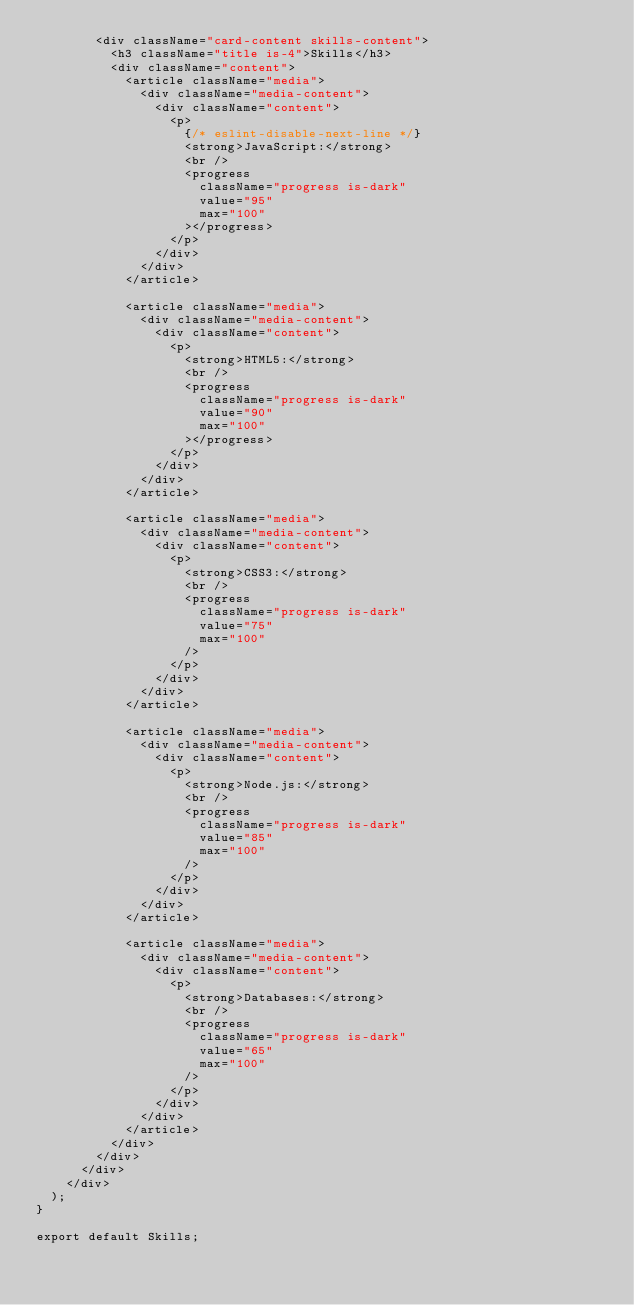<code> <loc_0><loc_0><loc_500><loc_500><_JavaScript_>        <div className="card-content skills-content">
          <h3 className="title is-4">Skills</h3>
          <div className="content">
            <article className="media">
              <div className="media-content">
                <div className="content">
                  <p>
                    {/* eslint-disable-next-line */}
                    <strong>JavaScript:</strong>
                    <br />
                    <progress
                      className="progress is-dark"
                      value="95"
                      max="100"
                    ></progress>
                  </p>
                </div>
              </div>
            </article>

            <article className="media">
              <div className="media-content">
                <div className="content">
                  <p>
                    <strong>HTML5:</strong>
                    <br />
                    <progress
                      className="progress is-dark"
                      value="90"
                      max="100"
                    ></progress>
                  </p>
                </div>
              </div>
            </article>

            <article className="media">
              <div className="media-content">
                <div className="content">
                  <p>
                    <strong>CSS3:</strong>
                    <br />
                    <progress
                      className="progress is-dark"
                      value="75"
                      max="100"
                    />
                  </p>
                </div>
              </div>
            </article>

            <article className="media">
              <div className="media-content">
                <div className="content">
                  <p>
                    <strong>Node.js:</strong>
                    <br />
                    <progress
                      className="progress is-dark"
                      value="85"
                      max="100"
                    />
                  </p>
                </div>
              </div>
            </article>

            <article className="media">
              <div className="media-content">
                <div className="content">
                  <p>
                    <strong>Databases:</strong>
                    <br />
                    <progress
                      className="progress is-dark"
                      value="65"
                      max="100"
                    />
                  </p>
                </div>
              </div>
            </article>
          </div>
        </div>
      </div>
    </div>
  );
}

export default Skills;
</code> 